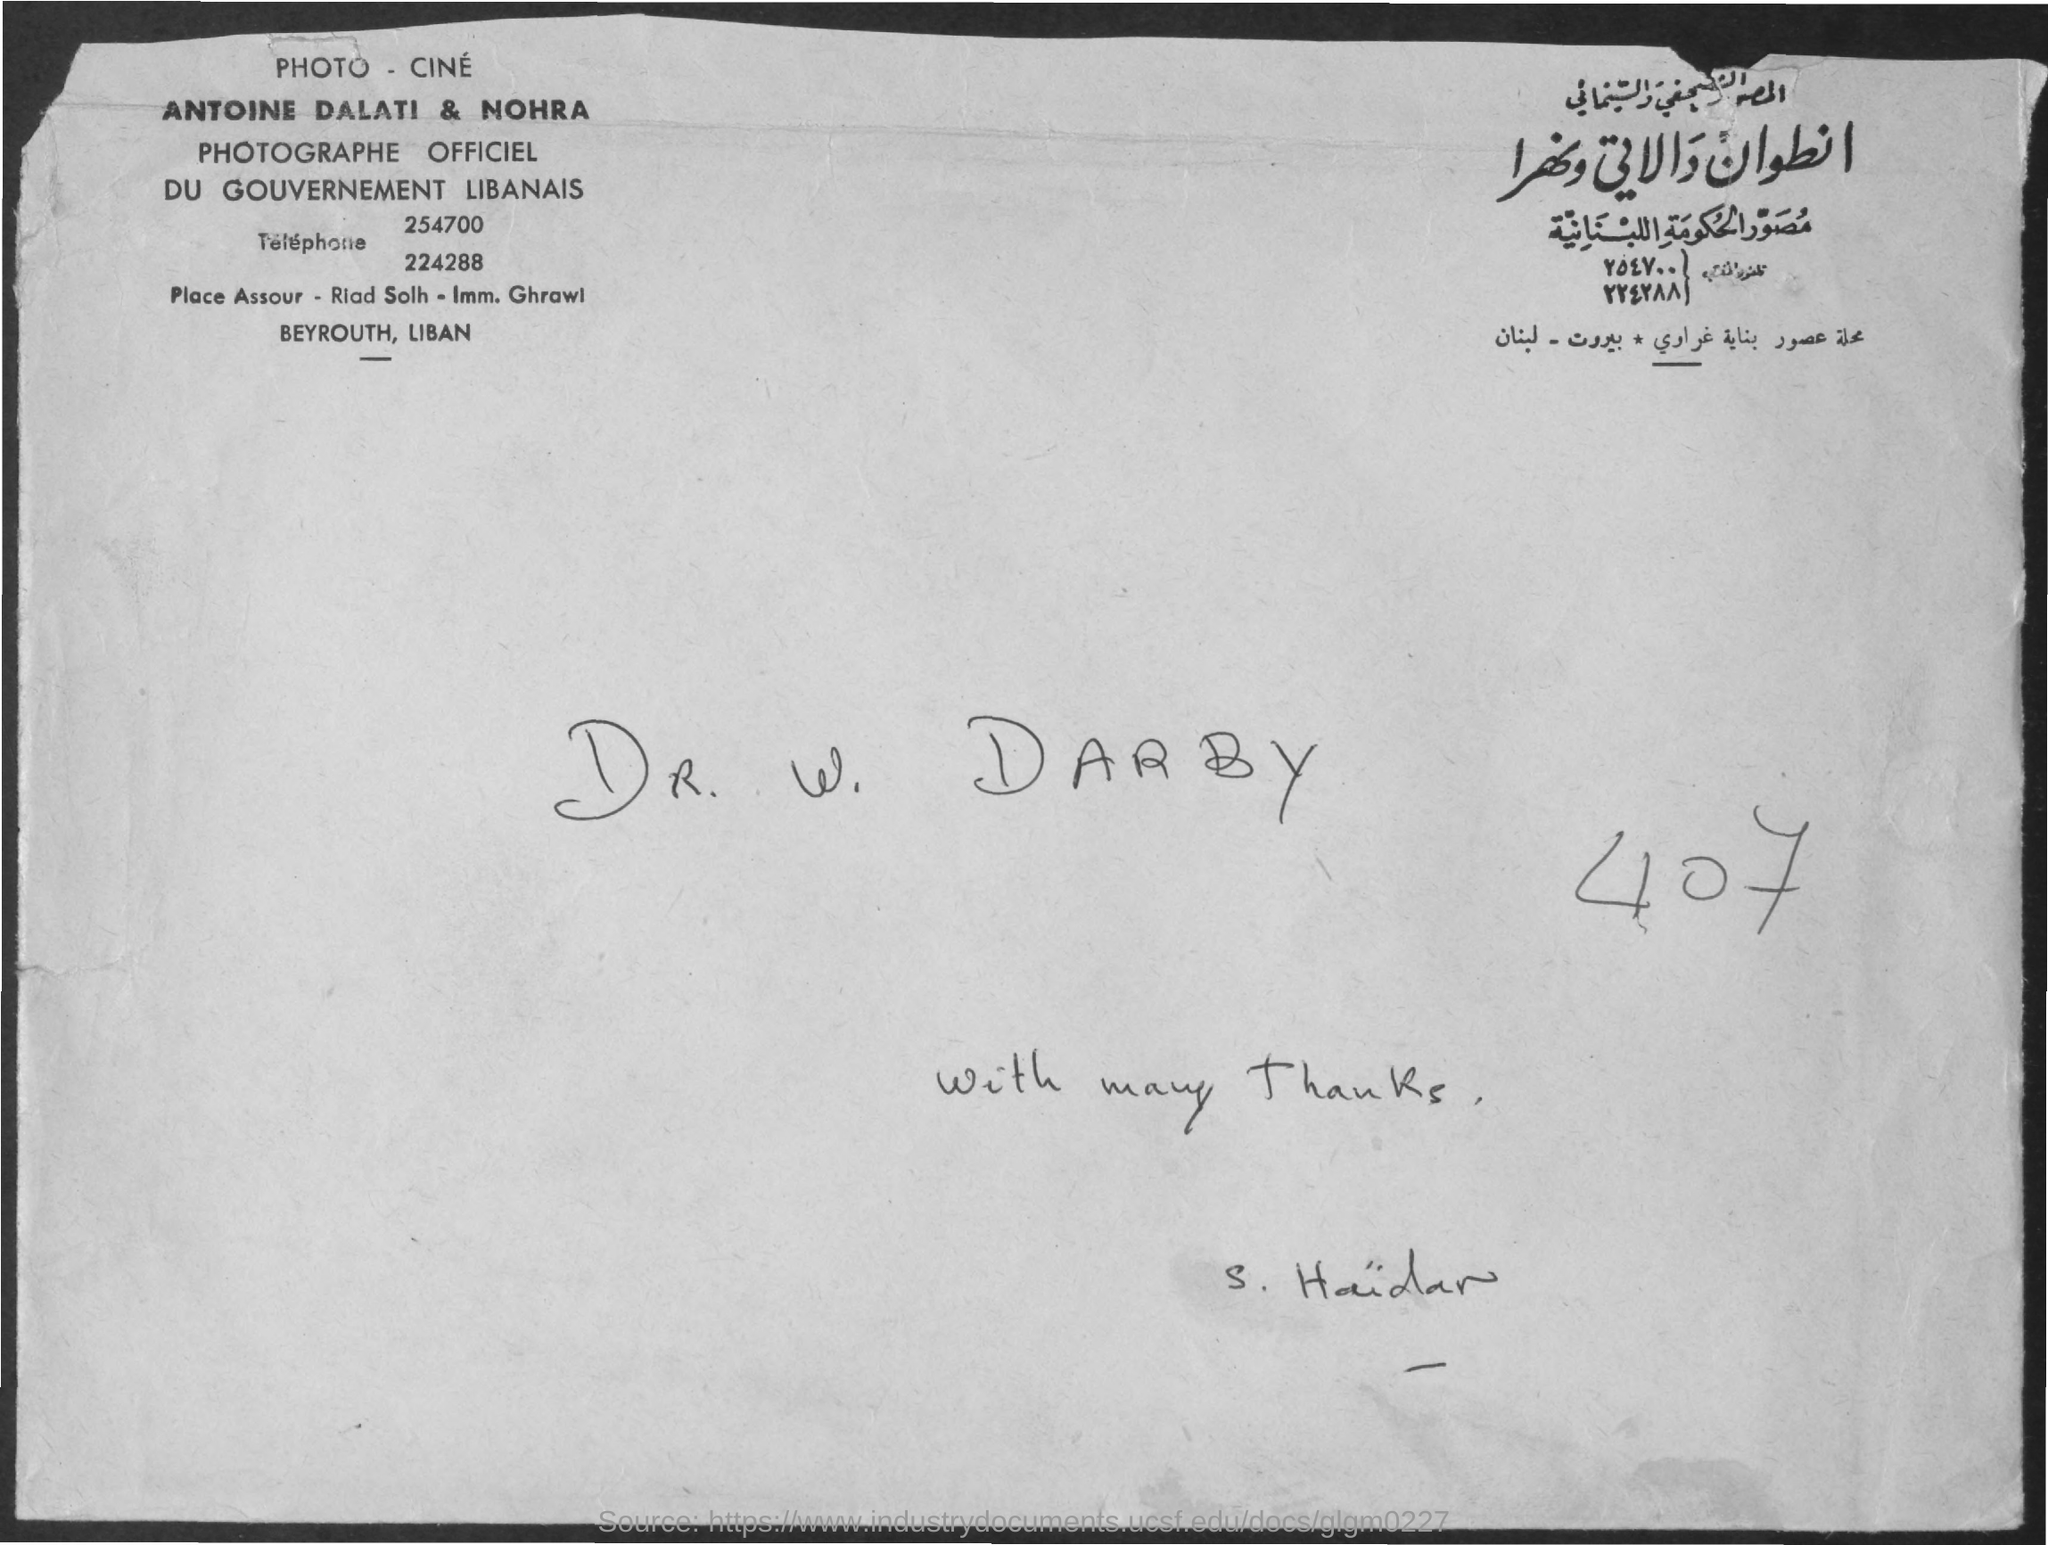What is the number mentioned in the document?
Keep it short and to the point. 407. Who all are the Photographe Officiel?
Your response must be concise. ANTOINE DALATI & NOHRA. 